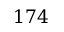<formula> <loc_0><loc_0><loc_500><loc_500>1 7 4</formula> 